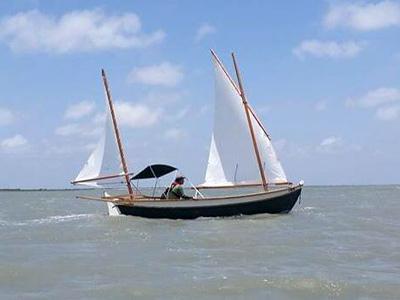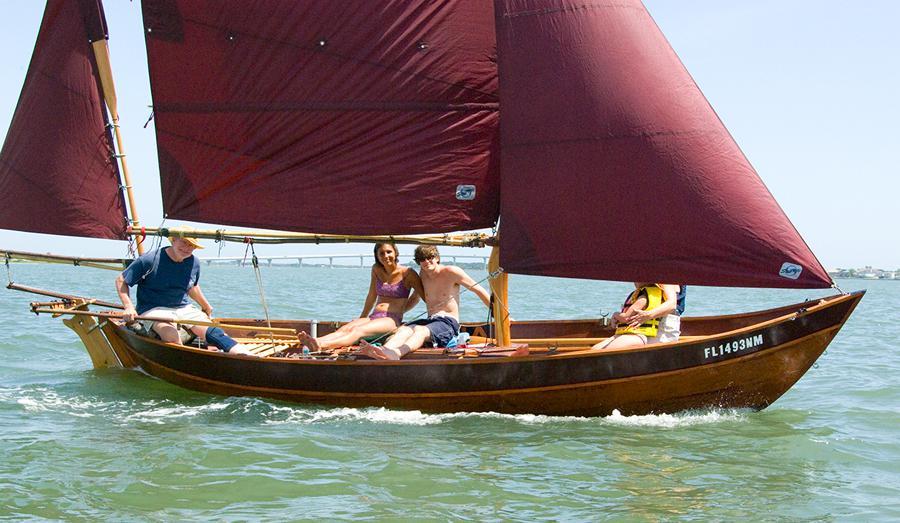The first image is the image on the left, the second image is the image on the right. Assess this claim about the two images: "In at least one image, the trees in the background are merely a short walk away.". Correct or not? Answer yes or no. No. The first image is the image on the left, the second image is the image on the right. Analyze the images presented: Is the assertion "the sails in the image on the right do not have the color white on them." valid? Answer yes or no. Yes. 